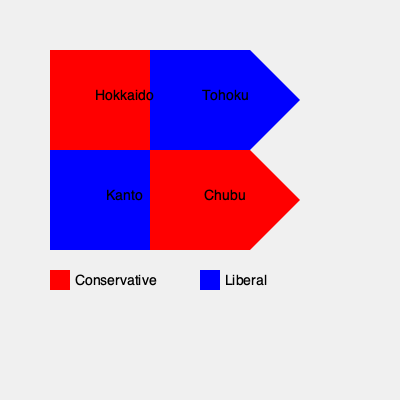Based on the color-coded map of Japan's regions, which areas show stronger support for traditional conservative values and policies? To answer this question, we need to analyze the color-coded map of Japan's regions:

1. The map shows four major regions of Japan: Hokkaido, Tohoku, Kanto, and Chubu.
2. The legend indicates that red represents Conservative areas, while blue represents Liberal areas.
3. Examining the map:
   a. Hokkaido (top-left) is colored red, indicating conservative support.
   b. Tohoku (top-right) is colored blue, suggesting liberal leanings.
   c. Kanto (bottom-left) is colored blue, also indicating liberal tendencies.
   d. Chubu (bottom-right) is colored red, showing conservative support.
4. The regions colored red (Hokkaido and Chubu) demonstrate stronger support for traditional conservative values and policies.

These areas are likely to favor policies that align with right-wing ideologies, such as stricter immigration controls, emphasis on traditional Japanese values, and a stronger national defense.
Answer: Hokkaido and Chubu 